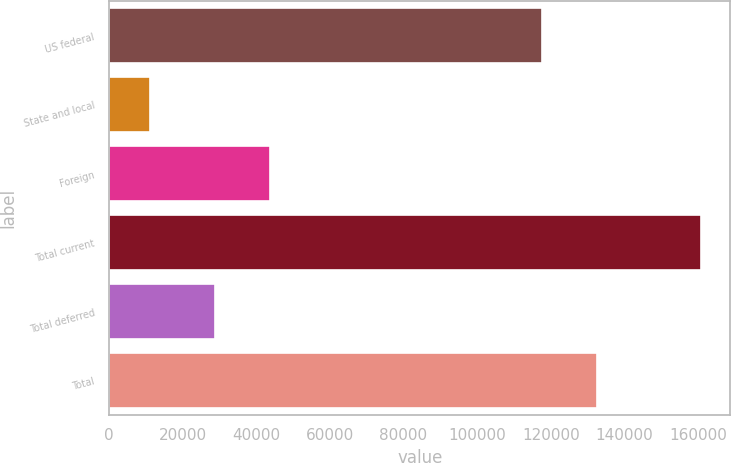<chart> <loc_0><loc_0><loc_500><loc_500><bar_chart><fcel>US federal<fcel>State and local<fcel>Foreign<fcel>Total current<fcel>Total deferred<fcel>Total<nl><fcel>117602<fcel>11175<fcel>43841.3<fcel>160758<fcel>28883<fcel>132560<nl></chart> 